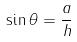Convert formula to latex. <formula><loc_0><loc_0><loc_500><loc_500>\sin \theta = \frac { a } { h }</formula> 